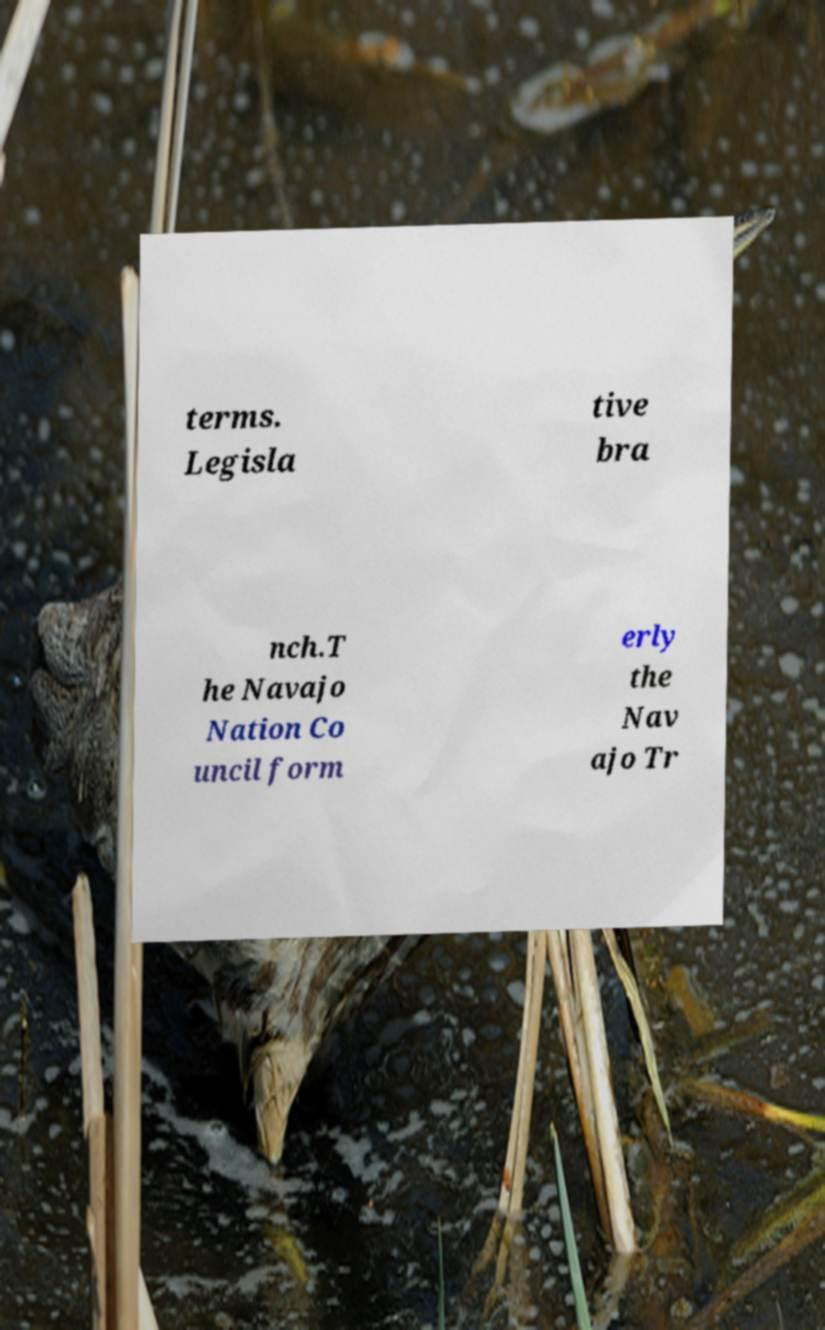There's text embedded in this image that I need extracted. Can you transcribe it verbatim? terms. Legisla tive bra nch.T he Navajo Nation Co uncil form erly the Nav ajo Tr 